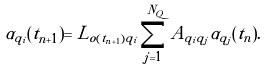<formula> <loc_0><loc_0><loc_500><loc_500>\alpha _ { q _ { i } } ( t _ { n + 1 } ) = L _ { o ( t _ { n + 1 } ) q _ { i } } \sum _ { j = 1 } ^ { N _ { Q } } A _ { q _ { i } q _ { j } } \alpha _ { q _ { j } } ( t _ { n } ) .</formula> 